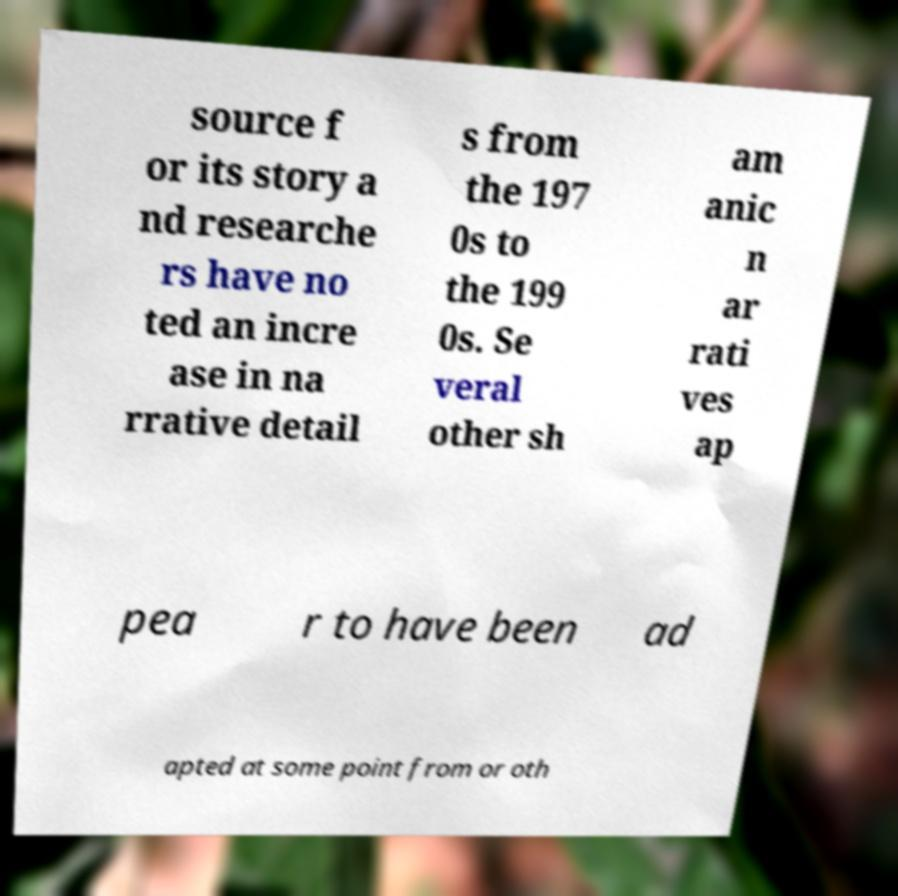Can you read and provide the text displayed in the image?This photo seems to have some interesting text. Can you extract and type it out for me? source f or its story a nd researche rs have no ted an incre ase in na rrative detail s from the 197 0s to the 199 0s. Se veral other sh am anic n ar rati ves ap pea r to have been ad apted at some point from or oth 